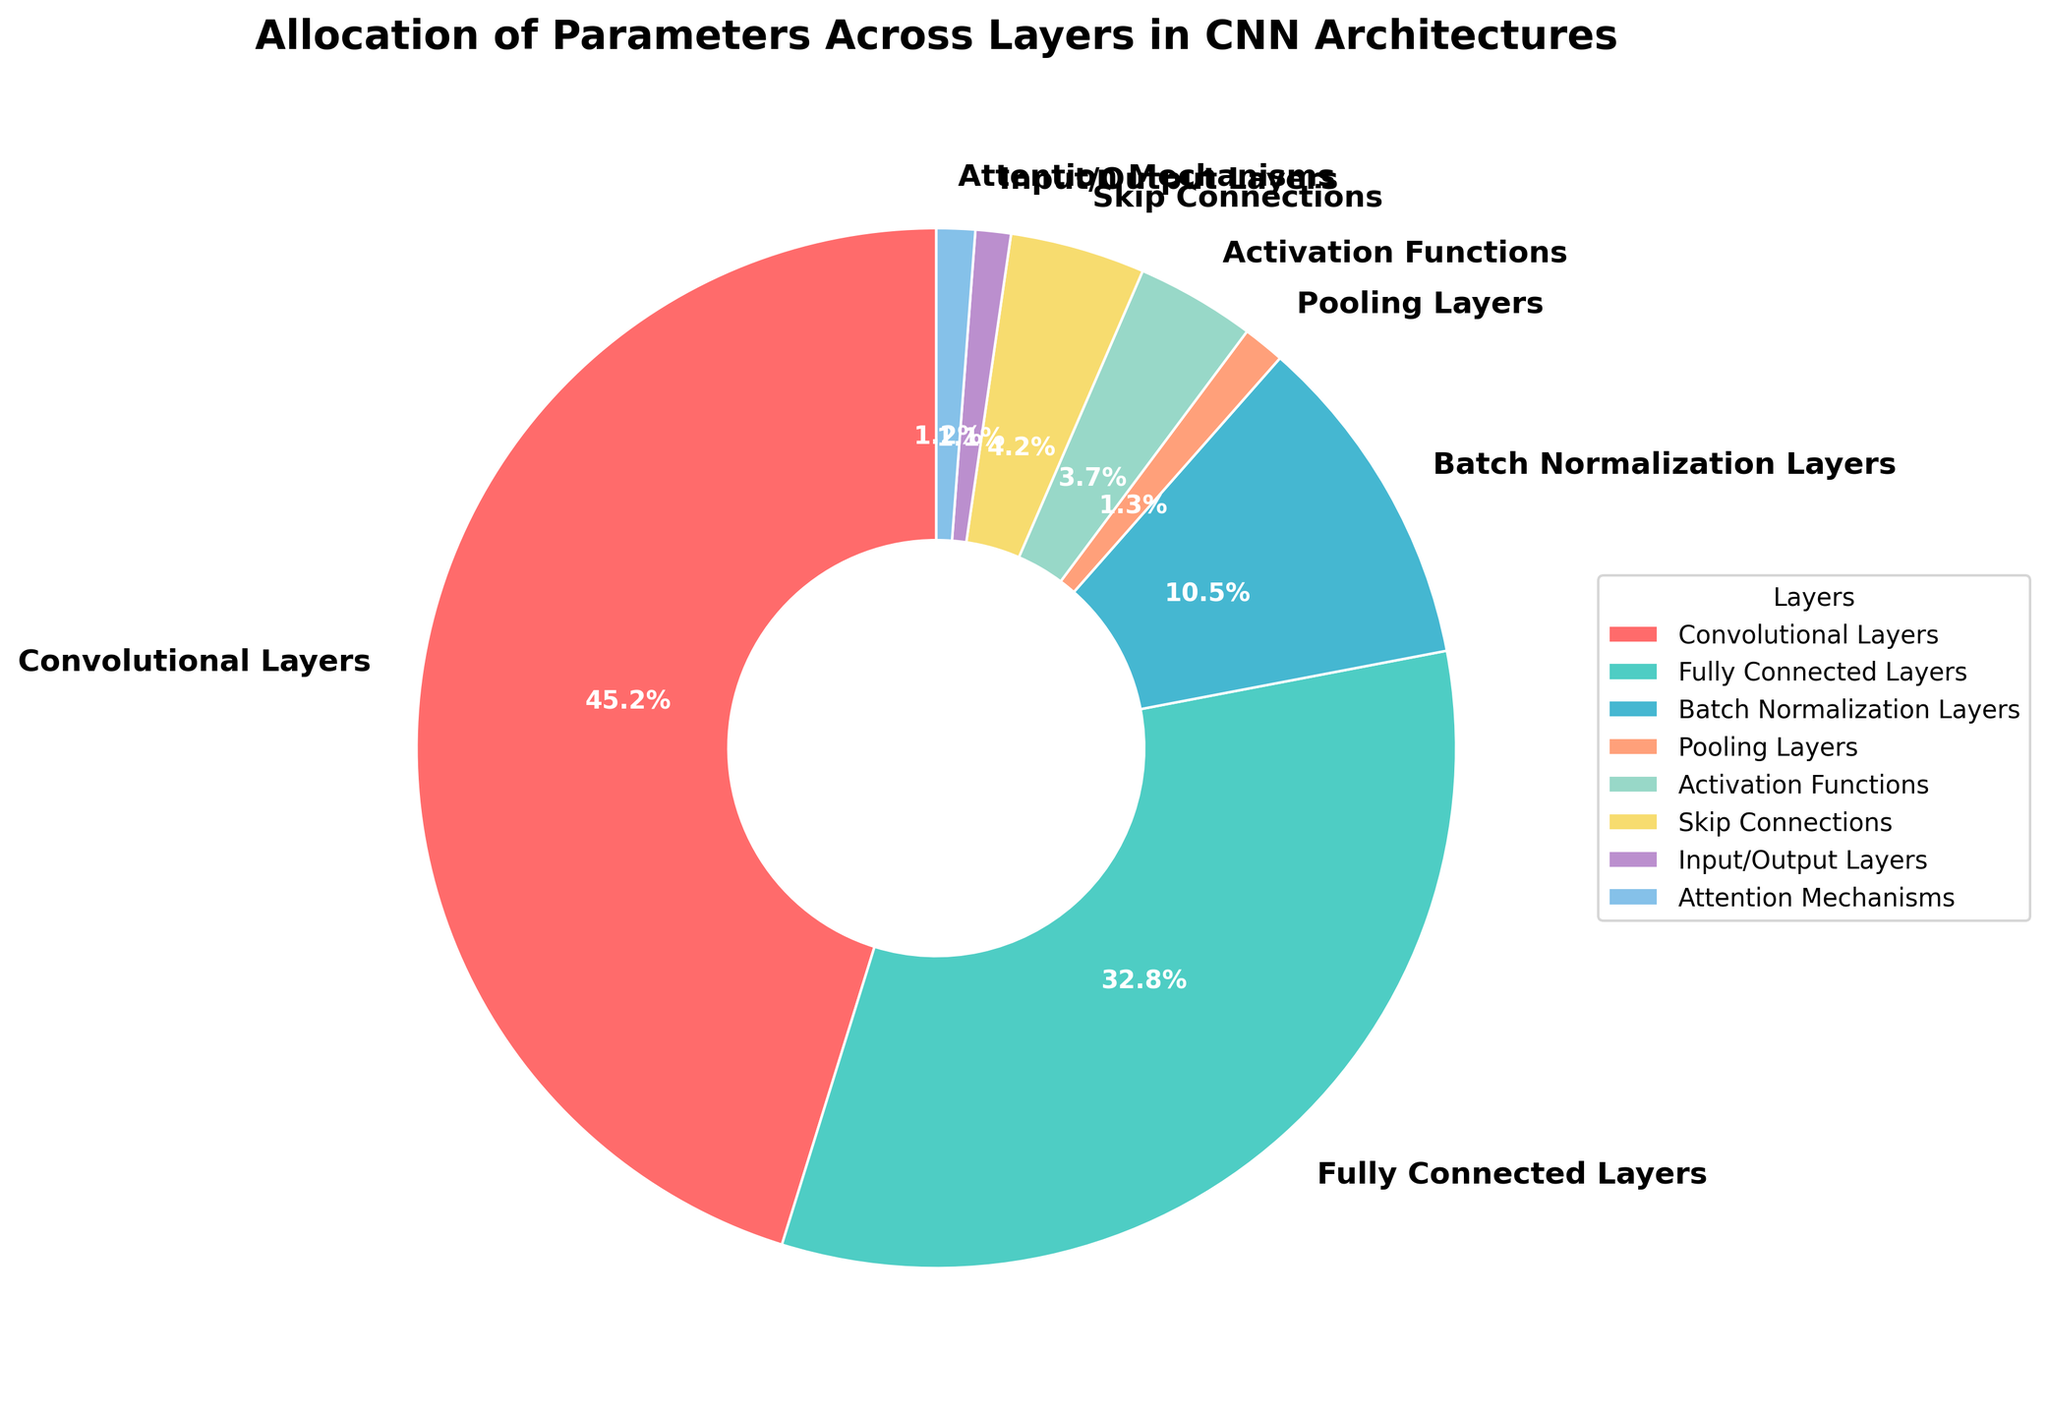Which layer has the highest percentage of parameters? By inspecting the pie chart, we notice that the Convolutional Layers have the largest section with 45.2%.
Answer: Convolutional Layers Which layer has a higher percentage of parameters: Activation Functions or Skip Connections? By comparing the pie sections visually, Activation Functions have 3.7% while Skip Connections have 4.2%. Therefore, Skip Connections have a higher percentage.
Answer: Skip Connections What is the total percentage of parameters for Activation Functions and Attention Mechanisms combined? By summing up the percentages of Activation Functions and Attention Mechanisms (3.7 + 1.2), we get 4.9%.
Answer: 4.9% How does the percentage of parameters in Pooling Layers compare to that in Input/Output Layers? The pie chart shows that Pooling Layers have 1.3% of parameters, while Input/Output Layers have 1.1%. Thus, Pooling Layers have a slightly higher percentage.
Answer: Pooling Layers What percentage of parameters is allocated to layers other than Convolutional and Fully Connected Layers? To find the percentage of parameters in layers other than Convolutional and Fully Connected Layers, we sum the other percentages: 10.5 (Batch Normalization) + 1.3 (Pooling) + 3.7 (Activation Functions) + 4.2 (Skip Connections) + 1.1 (Input/Output) + 1.2 (Attention Mechanisms). The total is 21.9%.
Answer: 21.9% Which layer has the smallest percentage of parameters? By looking at the smallest section in the pie chart, we see that Input/Output Layers have the smallest percentage with 1.1%.
Answer: Input/Output Layers What's the combined percentage of parameters for Batch Normalization and Attention Mechanisms? Adding the percentages from the pie chart for Batch Normalization Layers (10.5%) and Attention Mechanisms (1.2%), we get 11.7%.
Answer: 11.7% Are there more parameters allocated to Batch Normalization Layers or to Activation Functions and Skip Connections combined? Adding the percentages of Activation Functions (3.7%) and Skip Connections (4.2%) gives us 7.9%. Since Batch Normalization Layers have 10.5%, it has more parameters.
Answer: Batch Normalization Layers How much more is the percentage of parameters in Convolutional Layers compared to Fully Connected Layers? Subtracting the percentage of Fully Connected Layers (32.8%) from Convolutional Layers (45.2%) gives us 12.4%.
Answer: 12.4% What proportion of the total percentage is occupied by Fully Connected Layers? The Fully Connected Layers occupy 32.8% of the total, so the proportion is 32.8/100. Simplifying, this is 0.328 or 32.8%.
Answer: 32.8% 